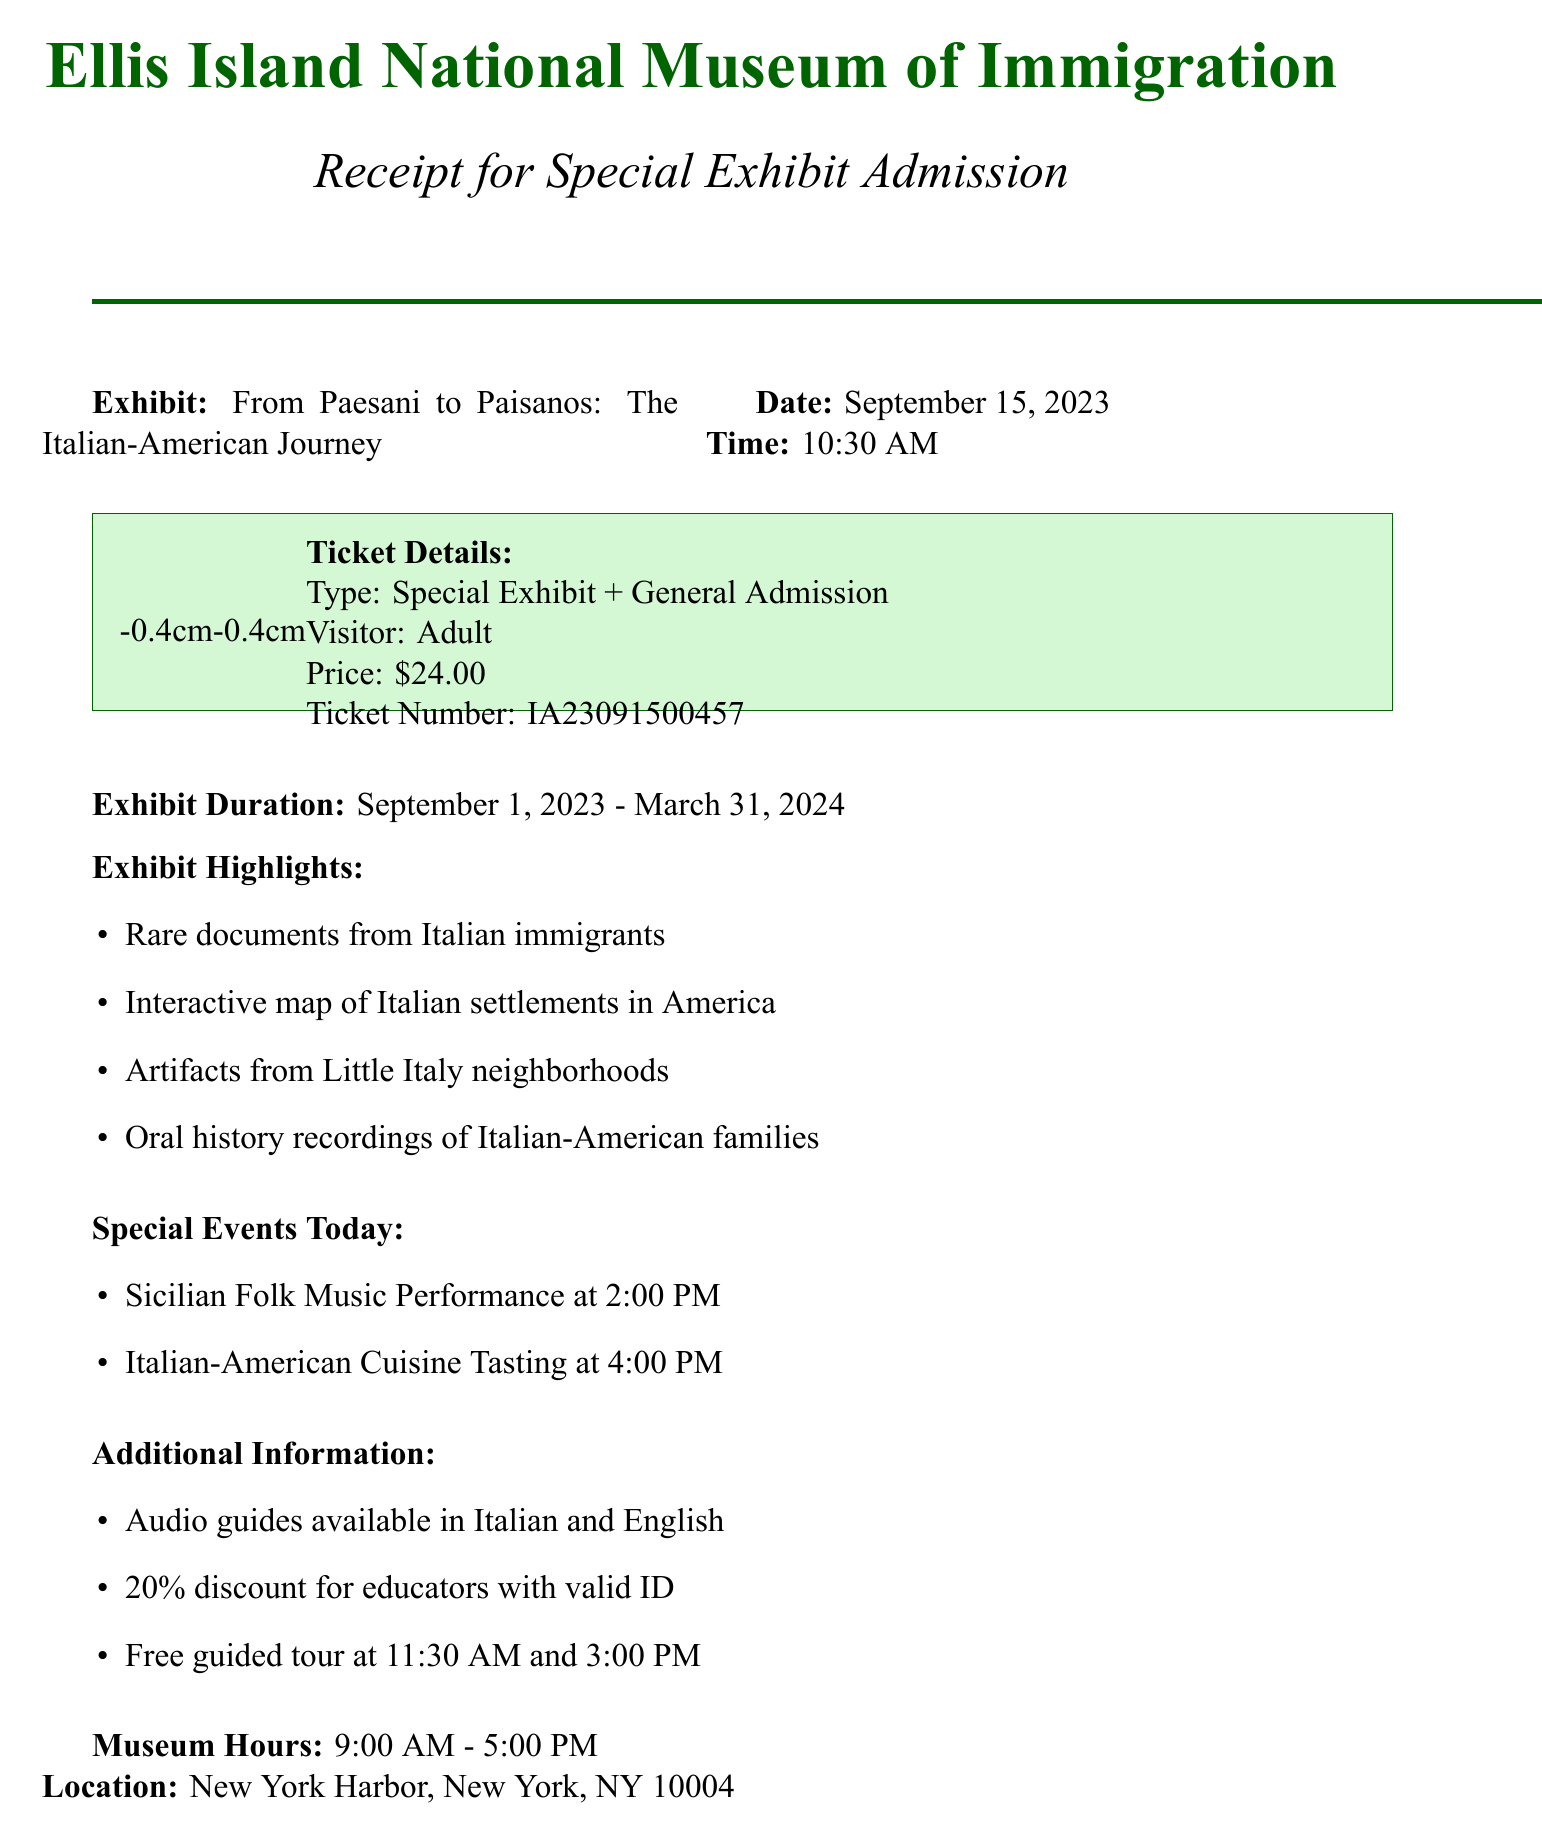What is the name of the museum? The name of the museum is mentioned at the top of the document.
Answer: Ellis Island National Museum of Immigration What is the ticket type? The ticket type is specified in the ticket details section of the document.
Answer: Special Exhibit + General Admission What is the price of the ticket? The price of the ticket is listed in the ticket details section.
Answer: $24.00 When does the exhibit end? The end date of the exhibit is stated in the exhibit duration section.
Answer: March 31, 2024 What is one highlight of the exhibit? Exhibit highlights are listed, and any of them can be an answer.
Answer: Rare documents from Italian immigrants What time is the Sicilian Folk Music Performance? The time for special events is noted in the special events section.
Answer: 2:00 PM How long is the museum open? Museum hours are listed towards the end of the document.
Answer: 9:00 AM - 5:00 PM Who is the curator of the exhibit? The curator's name is mentioned in the sponsorship section at the bottom.
Answer: Dr. Maria Laurino What is the location of the museum? The location is provided in the document's details.
Answer: New York Harbor, New York, NY 10004 